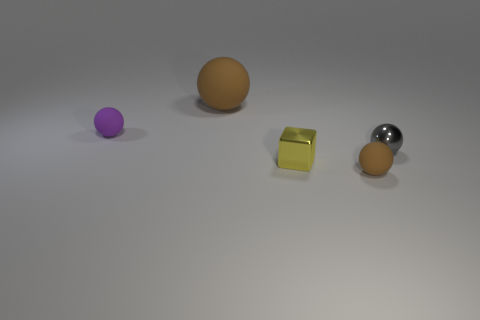What is the color of the tiny object in front of the tiny yellow cube?
Offer a very short reply. Brown. Is there a ball right of the small metallic object in front of the shiny thing right of the small brown matte ball?
Provide a short and direct response. Yes. Is the number of rubber objects to the right of the purple object greater than the number of big yellow blocks?
Your response must be concise. Yes. There is a brown rubber object in front of the gray shiny thing; does it have the same shape as the purple rubber object?
Ensure brevity in your answer.  Yes. Are there any other things that have the same material as the small yellow block?
Ensure brevity in your answer.  Yes. What number of objects are either big brown things or small purple objects to the left of the tiny yellow object?
Provide a short and direct response. 2. How big is the rubber thing that is behind the gray metallic object and in front of the large rubber object?
Offer a terse response. Small. Are there more tiny brown rubber balls on the right side of the small gray ball than tiny cubes that are on the left side of the yellow block?
Offer a very short reply. No. Do the yellow metal object and the brown object in front of the tiny metal cube have the same shape?
Provide a short and direct response. No. How many other objects are there of the same shape as the purple object?
Your response must be concise. 3. 